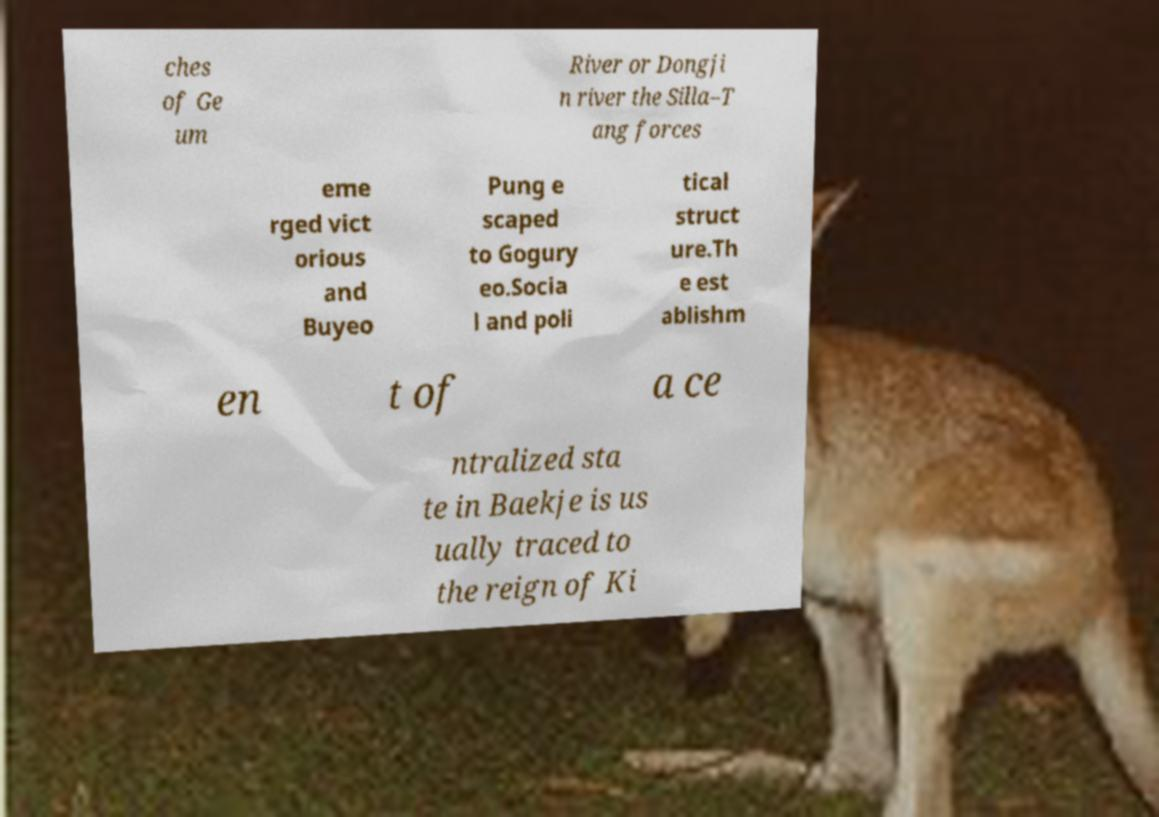Can you accurately transcribe the text from the provided image for me? ches of Ge um River or Dongji n river the Silla–T ang forces eme rged vict orious and Buyeo Pung e scaped to Gogury eo.Socia l and poli tical struct ure.Th e est ablishm en t of a ce ntralized sta te in Baekje is us ually traced to the reign of Ki 